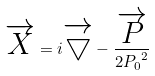<formula> <loc_0><loc_0><loc_500><loc_500>\overrightarrow { X } = i \overrightarrow { \bigtriangledown } - \frac { \overrightarrow { P } } { 2 { P _ { 0 } } ^ { 2 } }</formula> 